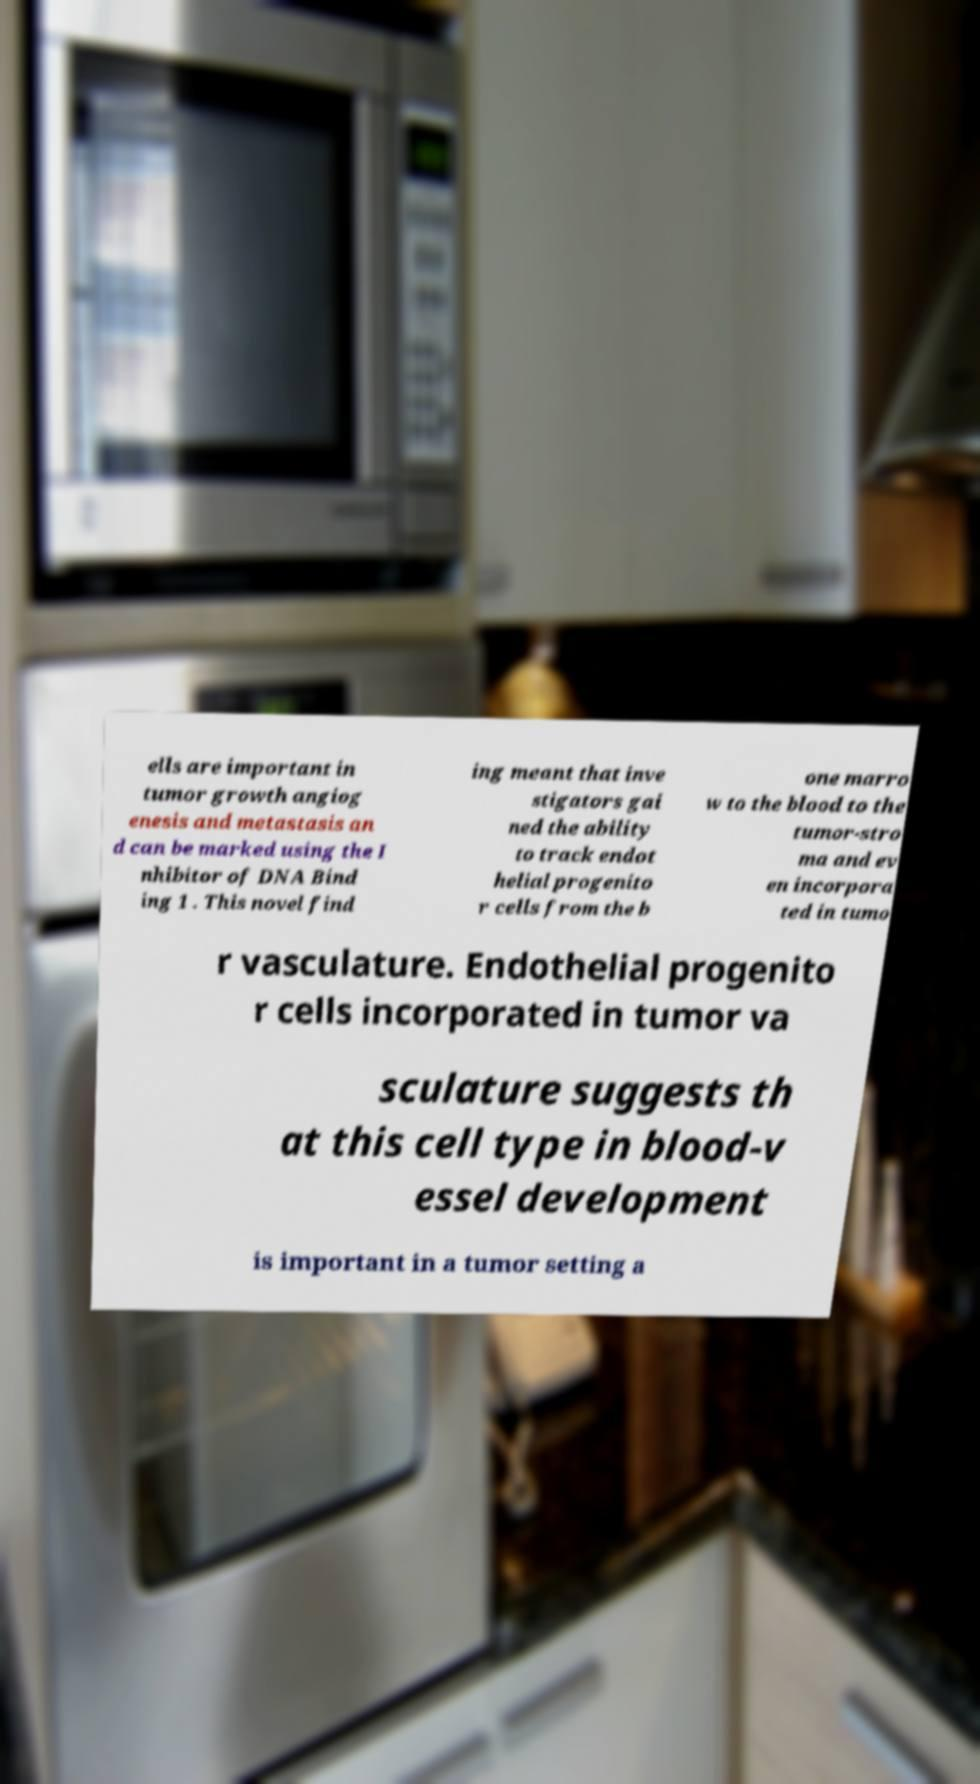Please identify and transcribe the text found in this image. ells are important in tumor growth angiog enesis and metastasis an d can be marked using the I nhibitor of DNA Bind ing 1 . This novel find ing meant that inve stigators gai ned the ability to track endot helial progenito r cells from the b one marro w to the blood to the tumor-stro ma and ev en incorpora ted in tumo r vasculature. Endothelial progenito r cells incorporated in tumor va sculature suggests th at this cell type in blood-v essel development is important in a tumor setting a 